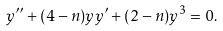<formula> <loc_0><loc_0><loc_500><loc_500>y ^ { \prime \prime } + ( 4 - n ) y y ^ { \prime } + ( 2 - n ) y ^ { 3 } = 0 .</formula> 